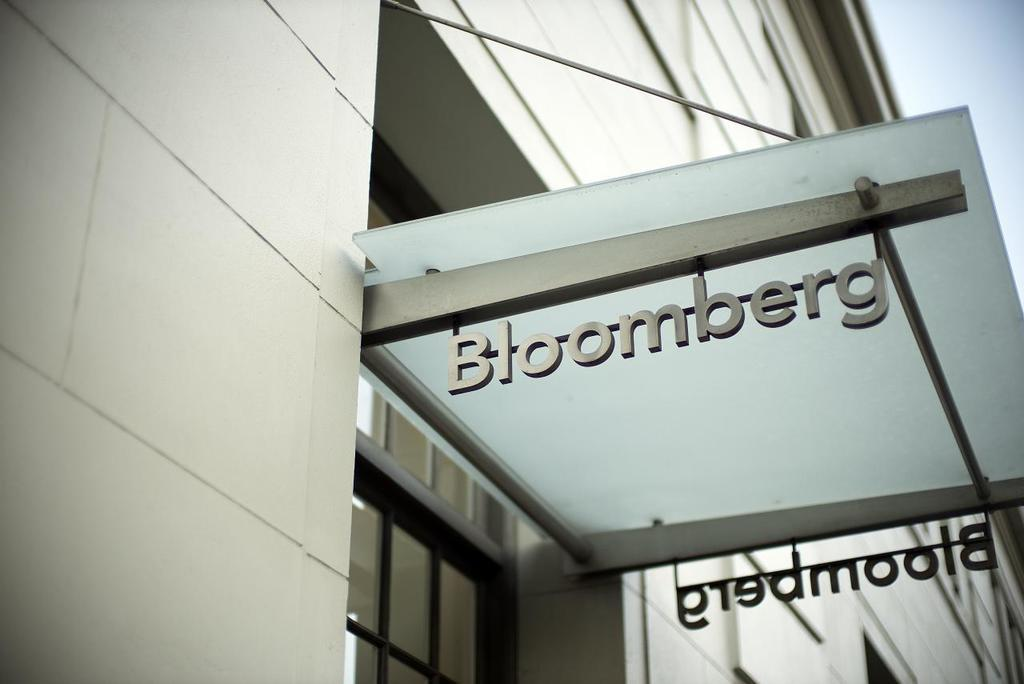What is present in the image that provides information or direction? There is a sign in the image. What type of information does the sign convey? The sign has a name related to the architecture of a building. How many pizzas are being played in a game of chess in the image? There are no pizzas or chess games present in the image. 